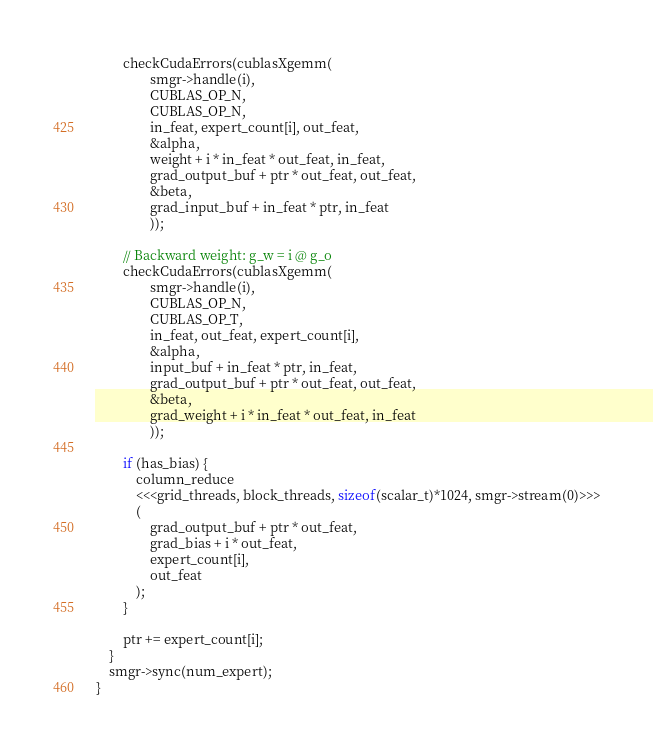<code> <loc_0><loc_0><loc_500><loc_500><_Cuda_>        checkCudaErrors(cublasXgemm(
                smgr->handle(i),
                CUBLAS_OP_N,
                CUBLAS_OP_N,
                in_feat, expert_count[i], out_feat,
                &alpha,
                weight + i * in_feat * out_feat, in_feat,
                grad_output_buf + ptr * out_feat, out_feat,
                &beta,
                grad_input_buf + in_feat * ptr, in_feat
                ));

        // Backward weight: g_w = i @ g_o
        checkCudaErrors(cublasXgemm(
                smgr->handle(i),
                CUBLAS_OP_N,
                CUBLAS_OP_T,
                in_feat, out_feat, expert_count[i],
                &alpha,
                input_buf + in_feat * ptr, in_feat,
                grad_output_buf + ptr * out_feat, out_feat,
                &beta,
                grad_weight + i * in_feat * out_feat, in_feat
                ));
        
        if (has_bias) {
            column_reduce
            <<<grid_threads, block_threads, sizeof(scalar_t)*1024, smgr->stream(0)>>>
            (
                grad_output_buf + ptr * out_feat,
                grad_bias + i * out_feat,
                expert_count[i],
                out_feat
            );
        }

        ptr += expert_count[i];
    }
    smgr->sync(num_expert);
}

</code> 